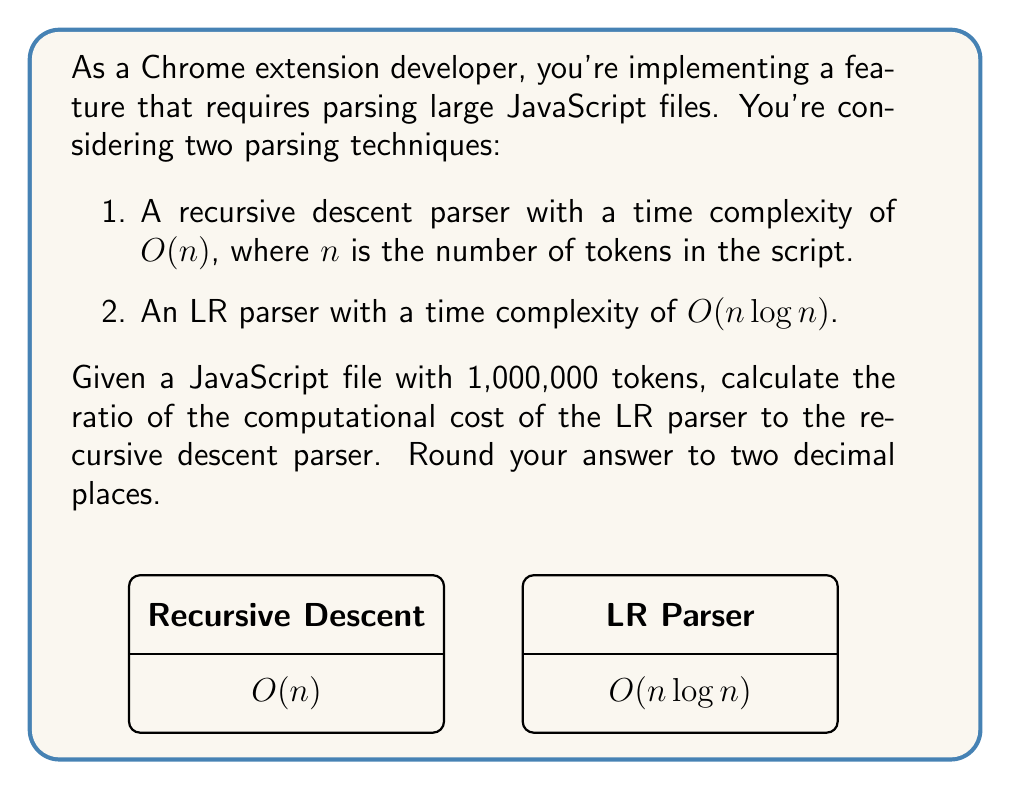Teach me how to tackle this problem. Let's approach this step-by-step:

1) First, let's define our variables:
   $n = 1,000,000$ (number of tokens)

2) For the recursive descent parser:
   Time complexity = $O(n)$
   Computational cost = $n = 1,000,000$

3) For the LR parser:
   Time complexity = $O(n \log n)$
   Computational cost = $n \log n = 1,000,000 \times \log(1,000,000)$

4) To calculate $\log(1,000,000)$:
   $1,000,000 = 10^6$
   $\log(1,000,000) = \log(10^6) = 6 \log(10) \approx 6 \times 2.30259 = 13.81554$

5) So, the computational cost for the LR parser:
   $1,000,000 \times 13.81554 = 13,815,540$

6) The ratio of LR parser cost to recursive descent parser cost:
   $\frac{13,815,540}{1,000,000} = 13.81554$

7) Rounding to two decimal places:
   $13.82$
Answer: $13.82$ 